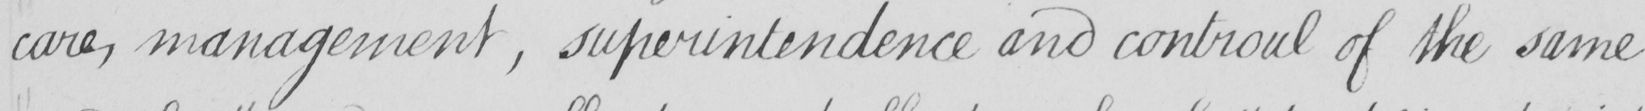What text is written in this handwritten line? care , management , superintendence and controul of the same 